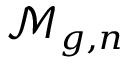<formula> <loc_0><loc_0><loc_500><loc_500>{ \mathcal { M } } _ { g , n }</formula> 